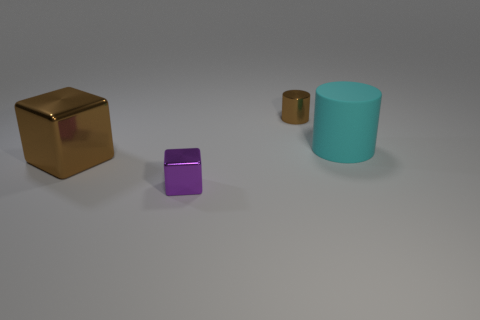Is there anything else that is made of the same material as the cyan object? From the image provided, it is not possible to conclusively determine the materials of the objects. However, based on the appearance and assuming all objects exhibit similar matte surfaces, there could be a chance that they are made from the same or similar types of plastic or painted material. To provide a more accurate answer, additional information or context would be required. 